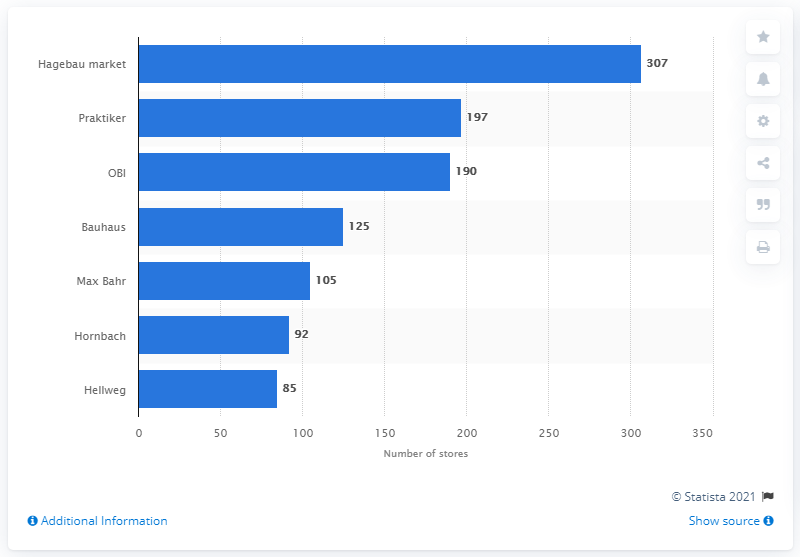Specify some key components in this picture. In 2013, OBI had 190 stores in Germany. In 2013, Praktiker had 197 stores in Germany. In 2013, Hagebau had a total of 307 stores in Germany. 